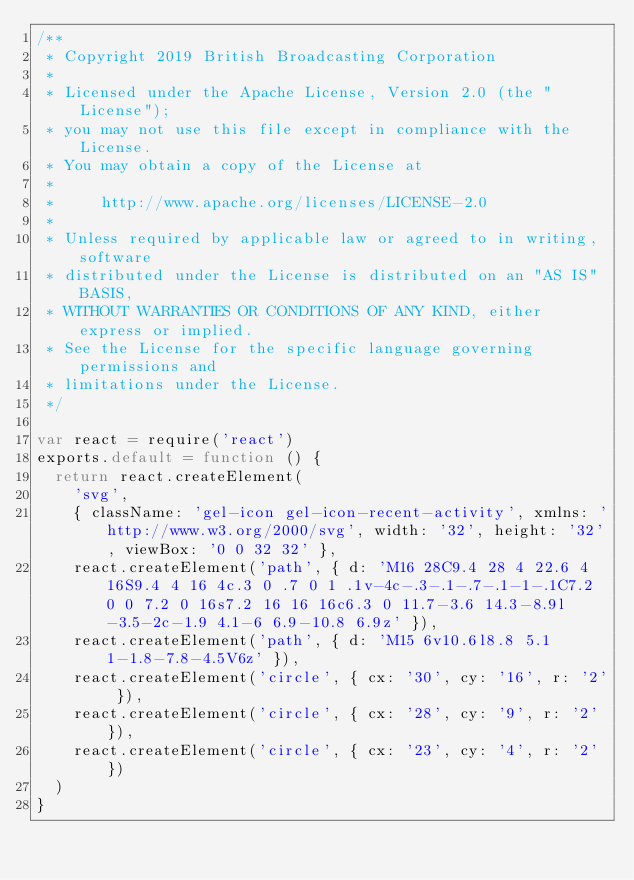<code> <loc_0><loc_0><loc_500><loc_500><_JavaScript_>/**
 * Copyright 2019 British Broadcasting Corporation
 *
 * Licensed under the Apache License, Version 2.0 (the "License");
 * you may not use this file except in compliance with the License.
 * You may obtain a copy of the License at
 *
 *     http://www.apache.org/licenses/LICENSE-2.0
 *
 * Unless required by applicable law or agreed to in writing, software
 * distributed under the License is distributed on an "AS IS" BASIS,
 * WITHOUT WARRANTIES OR CONDITIONS OF ANY KIND, either express or implied.
 * See the License for the specific language governing permissions and
 * limitations under the License.
 */

var react = require('react')
exports.default = function () {
  return react.createElement(
    'svg',
    { className: 'gel-icon gel-icon-recent-activity', xmlns: 'http://www.w3.org/2000/svg', width: '32', height: '32', viewBox: '0 0 32 32' },
    react.createElement('path', { d: 'M16 28C9.4 28 4 22.6 4 16S9.4 4 16 4c.3 0 .7 0 1 .1v-4c-.3-.1-.7-.1-1-.1C7.2 0 0 7.2 0 16s7.2 16 16 16c6.3 0 11.7-3.6 14.3-8.9l-3.5-2c-1.9 4.1-6 6.9-10.8 6.9z' }),
    react.createElement('path', { d: 'M15 6v10.6l8.8 5.1 1-1.8-7.8-4.5V6z' }),
    react.createElement('circle', { cx: '30', cy: '16', r: '2' }),
    react.createElement('circle', { cx: '28', cy: '9', r: '2' }),
    react.createElement('circle', { cx: '23', cy: '4', r: '2' })
  )
}
</code> 